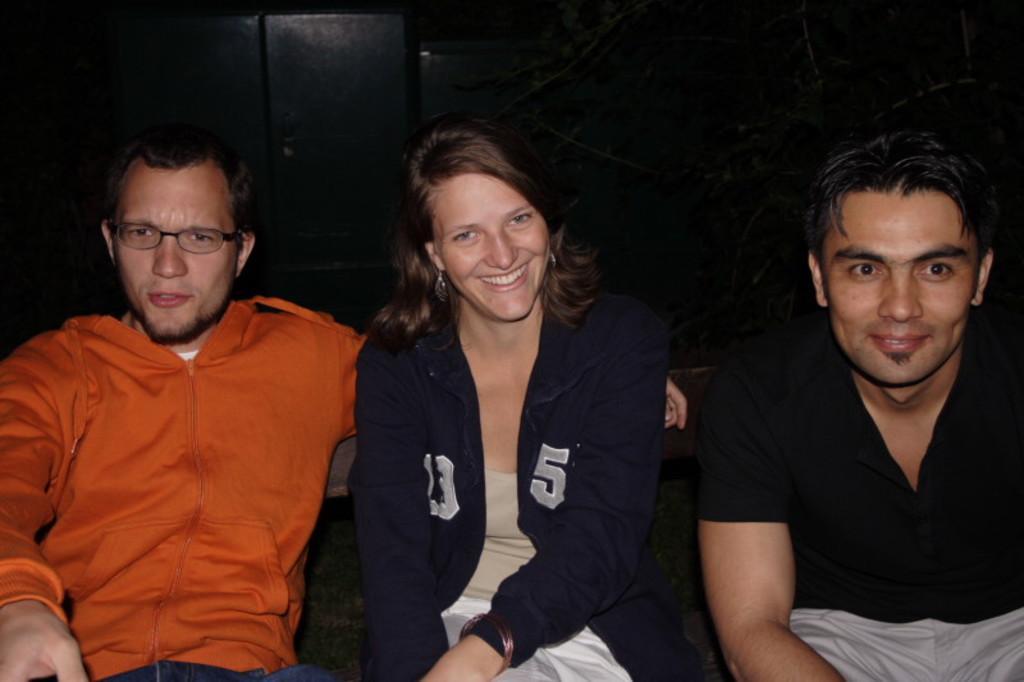Please provide a concise description of this image. In this image I can see two men and a woman are sitting. The woman is smiling and the man is wearing spectacles. The background of the image is dark. 